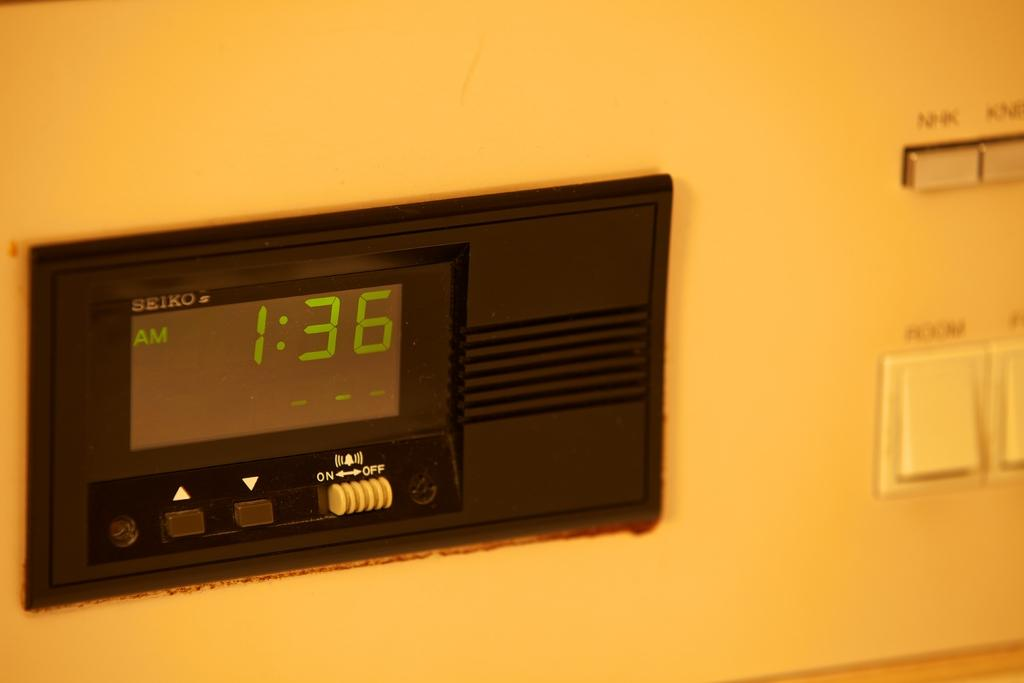What type of display board is in the image? There is a black color LED display board in the image. What features does the LED display board have? The LED display board has buttons. What part of the image is blurred? The right side of the image is blurred. What can be seen on the blurred right side of the image? There are switches and buttons visible on the blurred right side of the image. What type of wilderness can be seen through the window in the image? There is no window present in the image, so it is not possible to see any wilderness. 